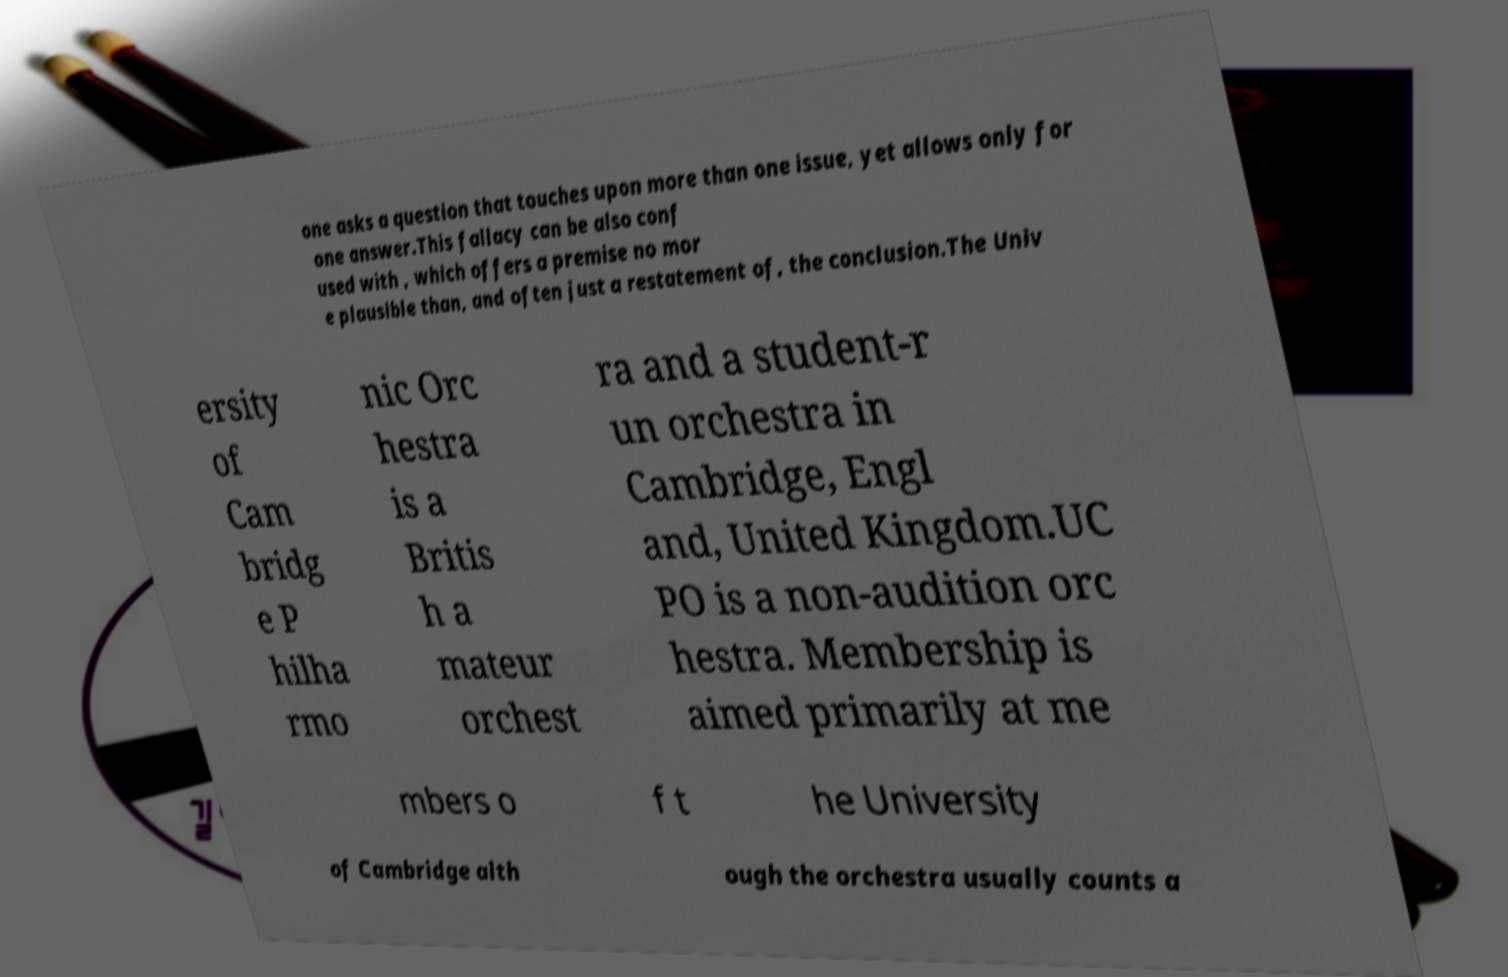Can you accurately transcribe the text from the provided image for me? one asks a question that touches upon more than one issue, yet allows only for one answer.This fallacy can be also conf used with , which offers a premise no mor e plausible than, and often just a restatement of, the conclusion.The Univ ersity of Cam bridg e P hilha rmo nic Orc hestra is a Britis h a mateur orchest ra and a student-r un orchestra in Cambridge, Engl and, United Kingdom.UC PO is a non-audition orc hestra. Membership is aimed primarily at me mbers o f t he University of Cambridge alth ough the orchestra usually counts a 